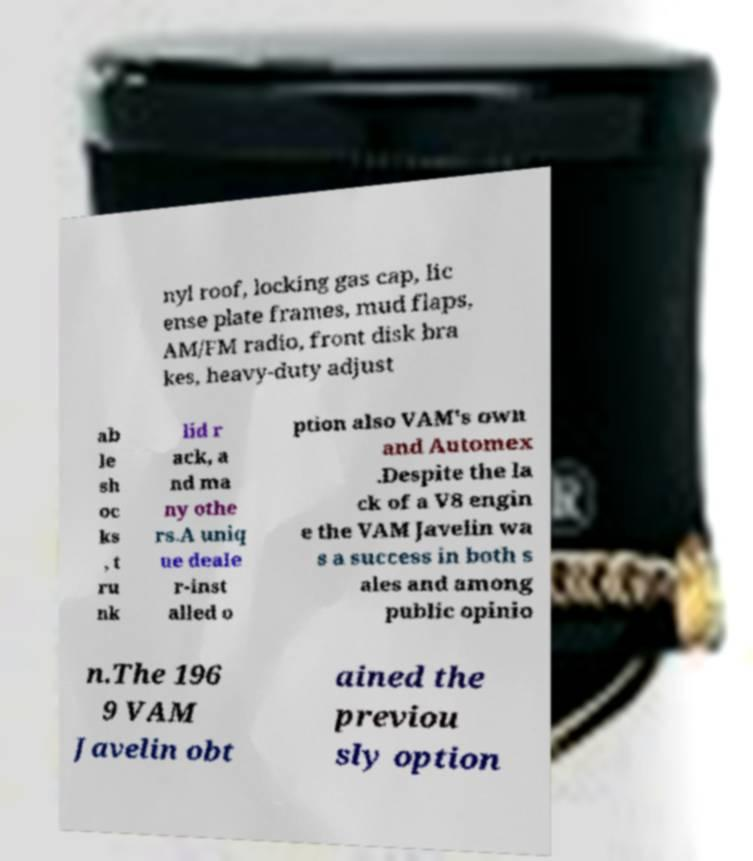For documentation purposes, I need the text within this image transcribed. Could you provide that? nyl roof, locking gas cap, lic ense plate frames, mud flaps, AM/FM radio, front disk bra kes, heavy-duty adjust ab le sh oc ks , t ru nk lid r ack, a nd ma ny othe rs.A uniq ue deale r-inst alled o ption also VAM's own and Automex .Despite the la ck of a V8 engin e the VAM Javelin wa s a success in both s ales and among public opinio n.The 196 9 VAM Javelin obt ained the previou sly option 